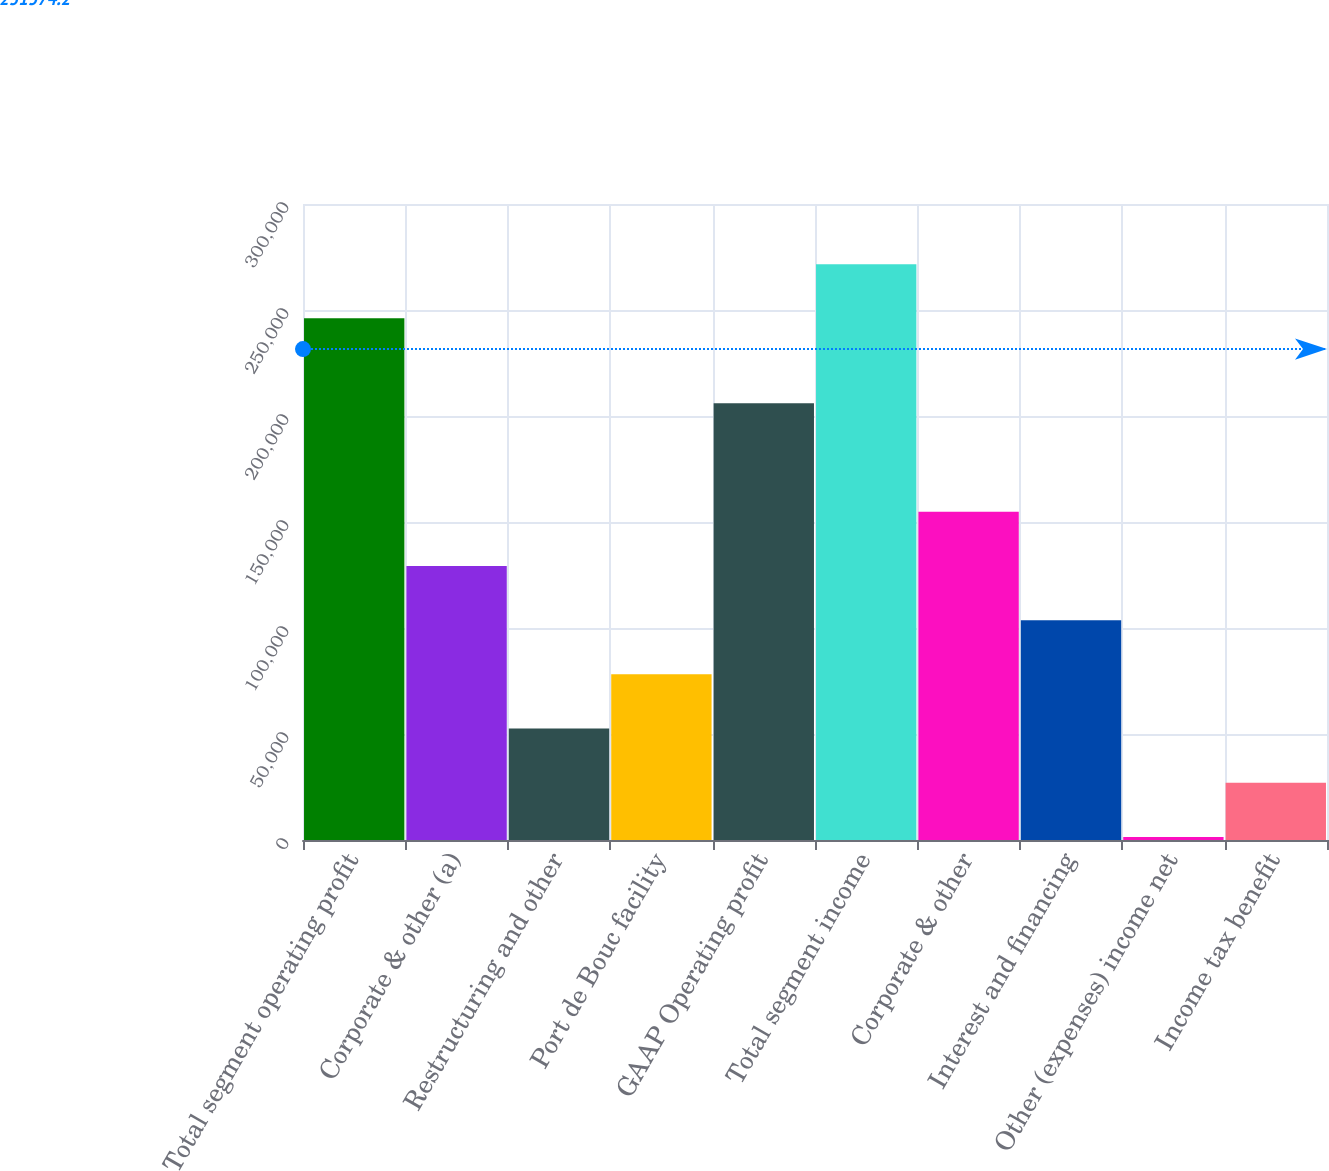<chart> <loc_0><loc_0><loc_500><loc_500><bar_chart><fcel>Total segment operating profit<fcel>Corporate & other (a)<fcel>Restructuring and other<fcel>Port de Bouc facility<fcel>GAAP Operating profit<fcel>Total segment income<fcel>Corporate & other<fcel>Interest and financing<fcel>Other (expenses) income net<fcel>Income tax benefit<nl><fcel>246060<fcel>129278<fcel>52565<fcel>78136<fcel>205991<fcel>271631<fcel>154849<fcel>103707<fcel>1423<fcel>26994<nl></chart> 